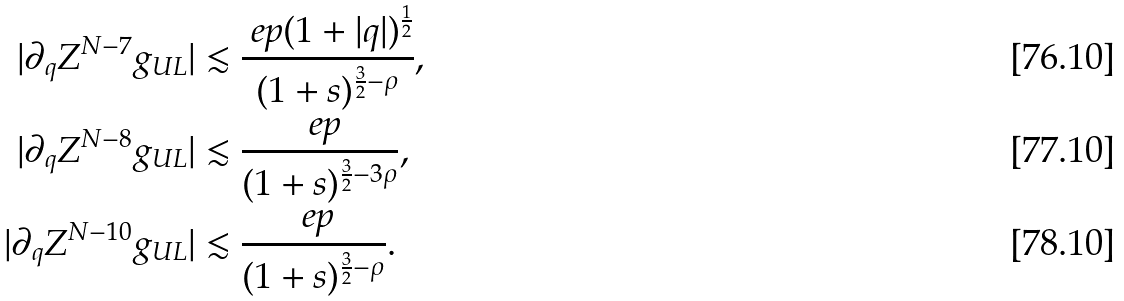Convert formula to latex. <formula><loc_0><loc_0><loc_500><loc_500>| \partial _ { q } Z ^ { N - 7 } g _ { U L } | & \lesssim \frac { \ e p ( 1 + | q | ) ^ { \frac { 1 } { 2 } } } { ( 1 + s ) ^ { \frac { 3 } { 2 } - \rho } } , \\ | \partial _ { q } Z ^ { N - 8 } g _ { U L } | & \lesssim \frac { \ e p } { ( 1 + s ) ^ { \frac { 3 } { 2 } - 3 \rho } } , \\ | \partial _ { q } Z ^ { N - 1 0 } g _ { U L } | & \lesssim \frac { \ e p } { ( 1 + s ) ^ { \frac { 3 } { 2 } - \rho } } .</formula> 